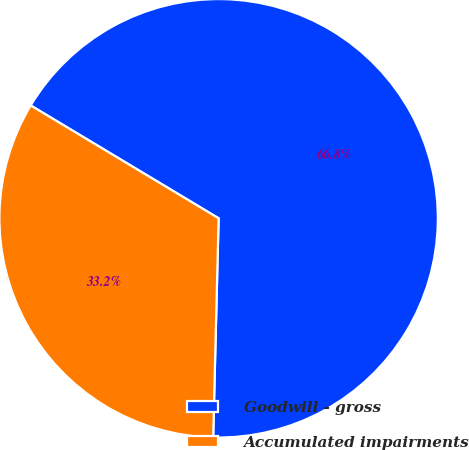<chart> <loc_0><loc_0><loc_500><loc_500><pie_chart><fcel>Goodwill - gross<fcel>Accumulated impairments<nl><fcel>66.79%<fcel>33.21%<nl></chart> 